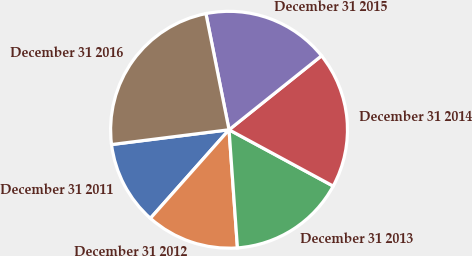<chart> <loc_0><loc_0><loc_500><loc_500><pie_chart><fcel>December 31 2011<fcel>December 31 2012<fcel>December 31 2013<fcel>December 31 2014<fcel>December 31 2015<fcel>December 31 2016<nl><fcel>11.45%<fcel>12.69%<fcel>15.98%<fcel>18.63%<fcel>17.39%<fcel>23.87%<nl></chart> 